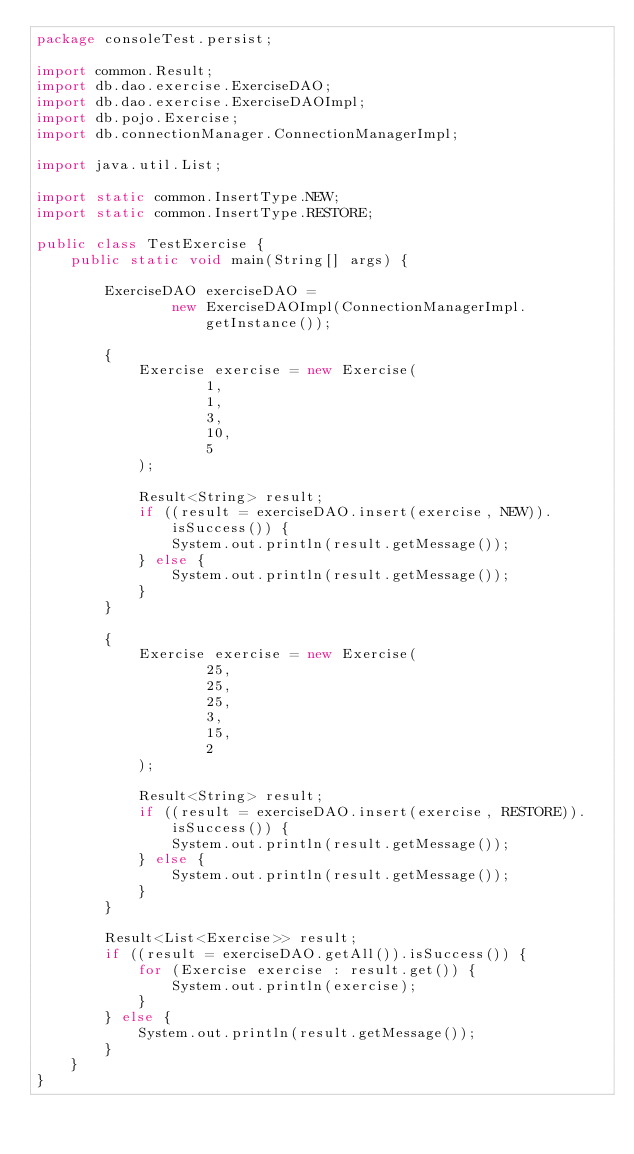Convert code to text. <code><loc_0><loc_0><loc_500><loc_500><_Java_>package consoleTest.persist;

import common.Result;
import db.dao.exercise.ExerciseDAO;
import db.dao.exercise.ExerciseDAOImpl;
import db.pojo.Exercise;
import db.connectionManager.ConnectionManagerImpl;

import java.util.List;

import static common.InsertType.NEW;
import static common.InsertType.RESTORE;

public class TestExercise {
    public static void main(String[] args) {

        ExerciseDAO exerciseDAO =
                new ExerciseDAOImpl(ConnectionManagerImpl.getInstance());

        {
            Exercise exercise = new Exercise(
                    1,
                    1,
                    3,
                    10,
                    5
            );

            Result<String> result;
            if ((result = exerciseDAO.insert(exercise, NEW)).isSuccess()) {
                System.out.println(result.getMessage());
            } else {
                System.out.println(result.getMessage());
            }
        }

        {
            Exercise exercise = new Exercise(
                    25,
                    25,
                    25,
                    3,
                    15,
                    2
            );

            Result<String> result;
            if ((result = exerciseDAO.insert(exercise, RESTORE)).isSuccess()) {
                System.out.println(result.getMessage());
            } else {
                System.out.println(result.getMessage());
            }
        }

        Result<List<Exercise>> result;
        if ((result = exerciseDAO.getAll()).isSuccess()) {
            for (Exercise exercise : result.get()) {
                System.out.println(exercise);
            }
        } else {
            System.out.println(result.getMessage());
        }
    }
}
</code> 